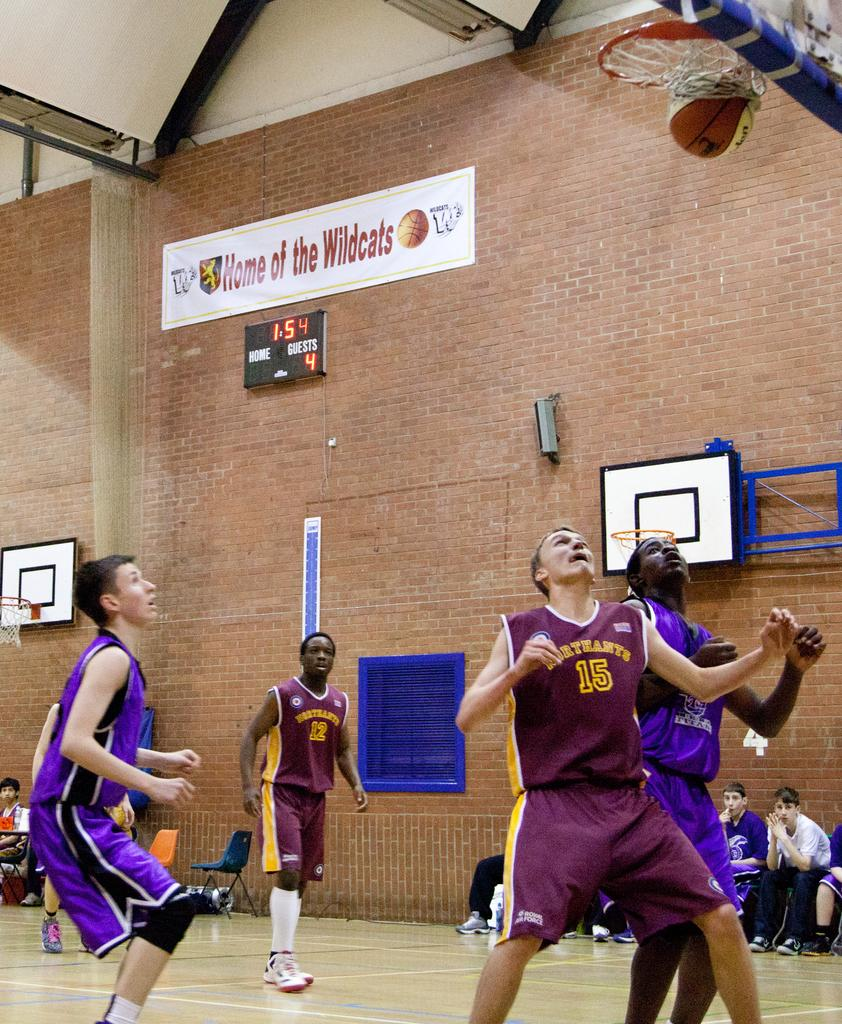<image>
Render a clear and concise summary of the photo. People playing basketball with 'Home of the Wildcats' on the wall behind. 